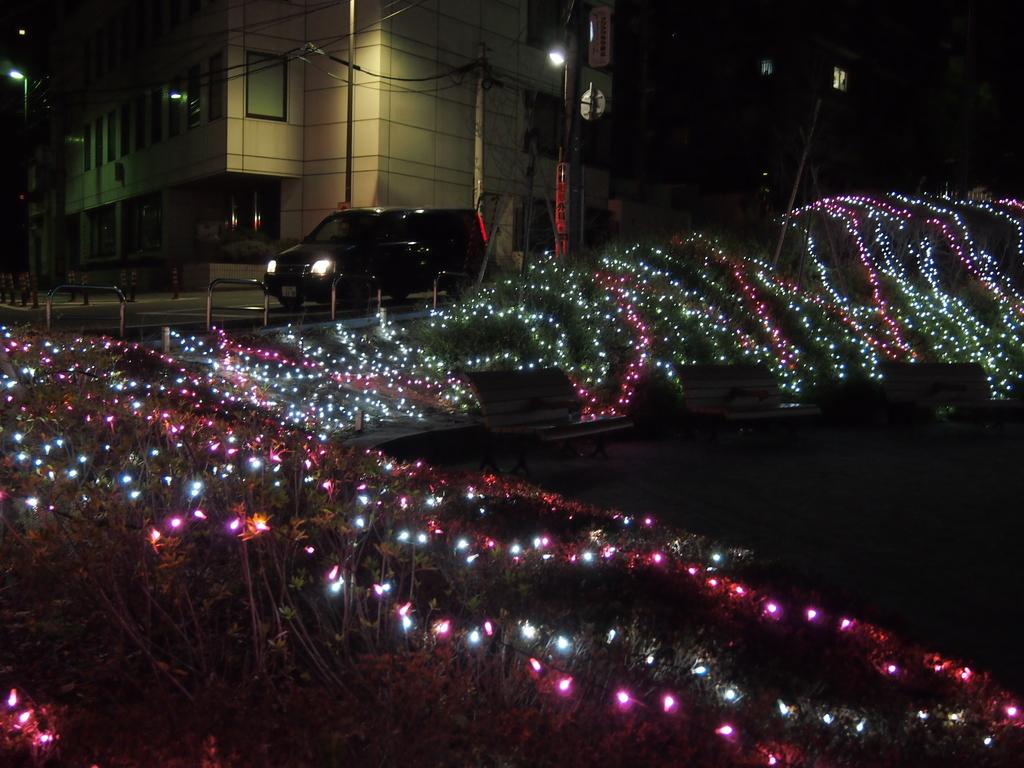What can be seen in the image that provides illumination? There are lights in the image. What is visible in the background of the image? There are poles in the background of the image. What type of object is present in the image that can transport people or goods? There is a vehicle in the image. What structures are present in the image that hold lights? There are light poles in the image. What is the color of the building in the image? The building is in cream color. Who is the writer in the image? There is no writer present in the image. What type of truck can be seen in the image? There is no truck present in the image. 